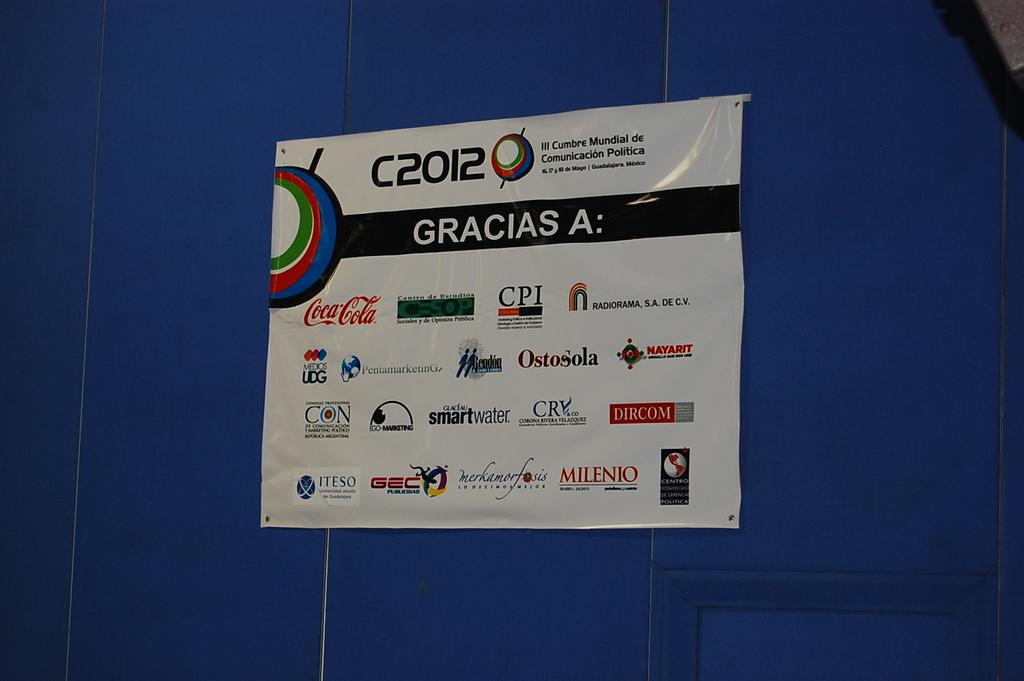Provide a one-sentence caption for the provided image. A poster with several logos on it hangs on a wall. 